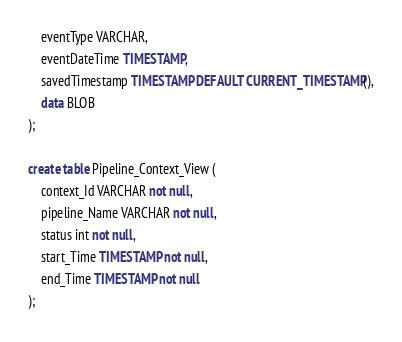<code> <loc_0><loc_0><loc_500><loc_500><_SQL_>    eventType VARCHAR,
    eventDateTime TIMESTAMP,
    savedTimestamp TIMESTAMP DEFAULT CURRENT_TIMESTAMP(),
    data BLOB
);

create table Pipeline_Context_View (
    context_Id VARCHAR not null,
    pipeline_Name VARCHAR not null,
    status int not null,
    start_Time TIMESTAMP not null,
    end_Time TIMESTAMP not null
);</code> 